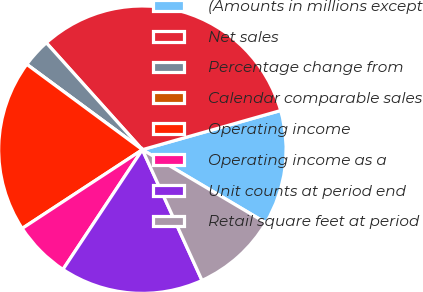<chart> <loc_0><loc_0><loc_500><loc_500><pie_chart><fcel>(Amounts in millions except<fcel>Net sales<fcel>Percentage change from<fcel>Calendar comparable sales<fcel>Operating income<fcel>Operating income as a<fcel>Unit counts at period end<fcel>Retail square feet at period<nl><fcel>12.9%<fcel>32.26%<fcel>3.23%<fcel>0.0%<fcel>19.35%<fcel>6.45%<fcel>16.13%<fcel>9.68%<nl></chart> 